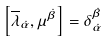Convert formula to latex. <formula><loc_0><loc_0><loc_500><loc_500>\left [ \overline { \lambda } _ { \dot { \alpha } } , { \mu } ^ { \dot { \beta } } \right ] = \delta _ { \dot { \alpha } } ^ { \dot { \beta } }</formula> 